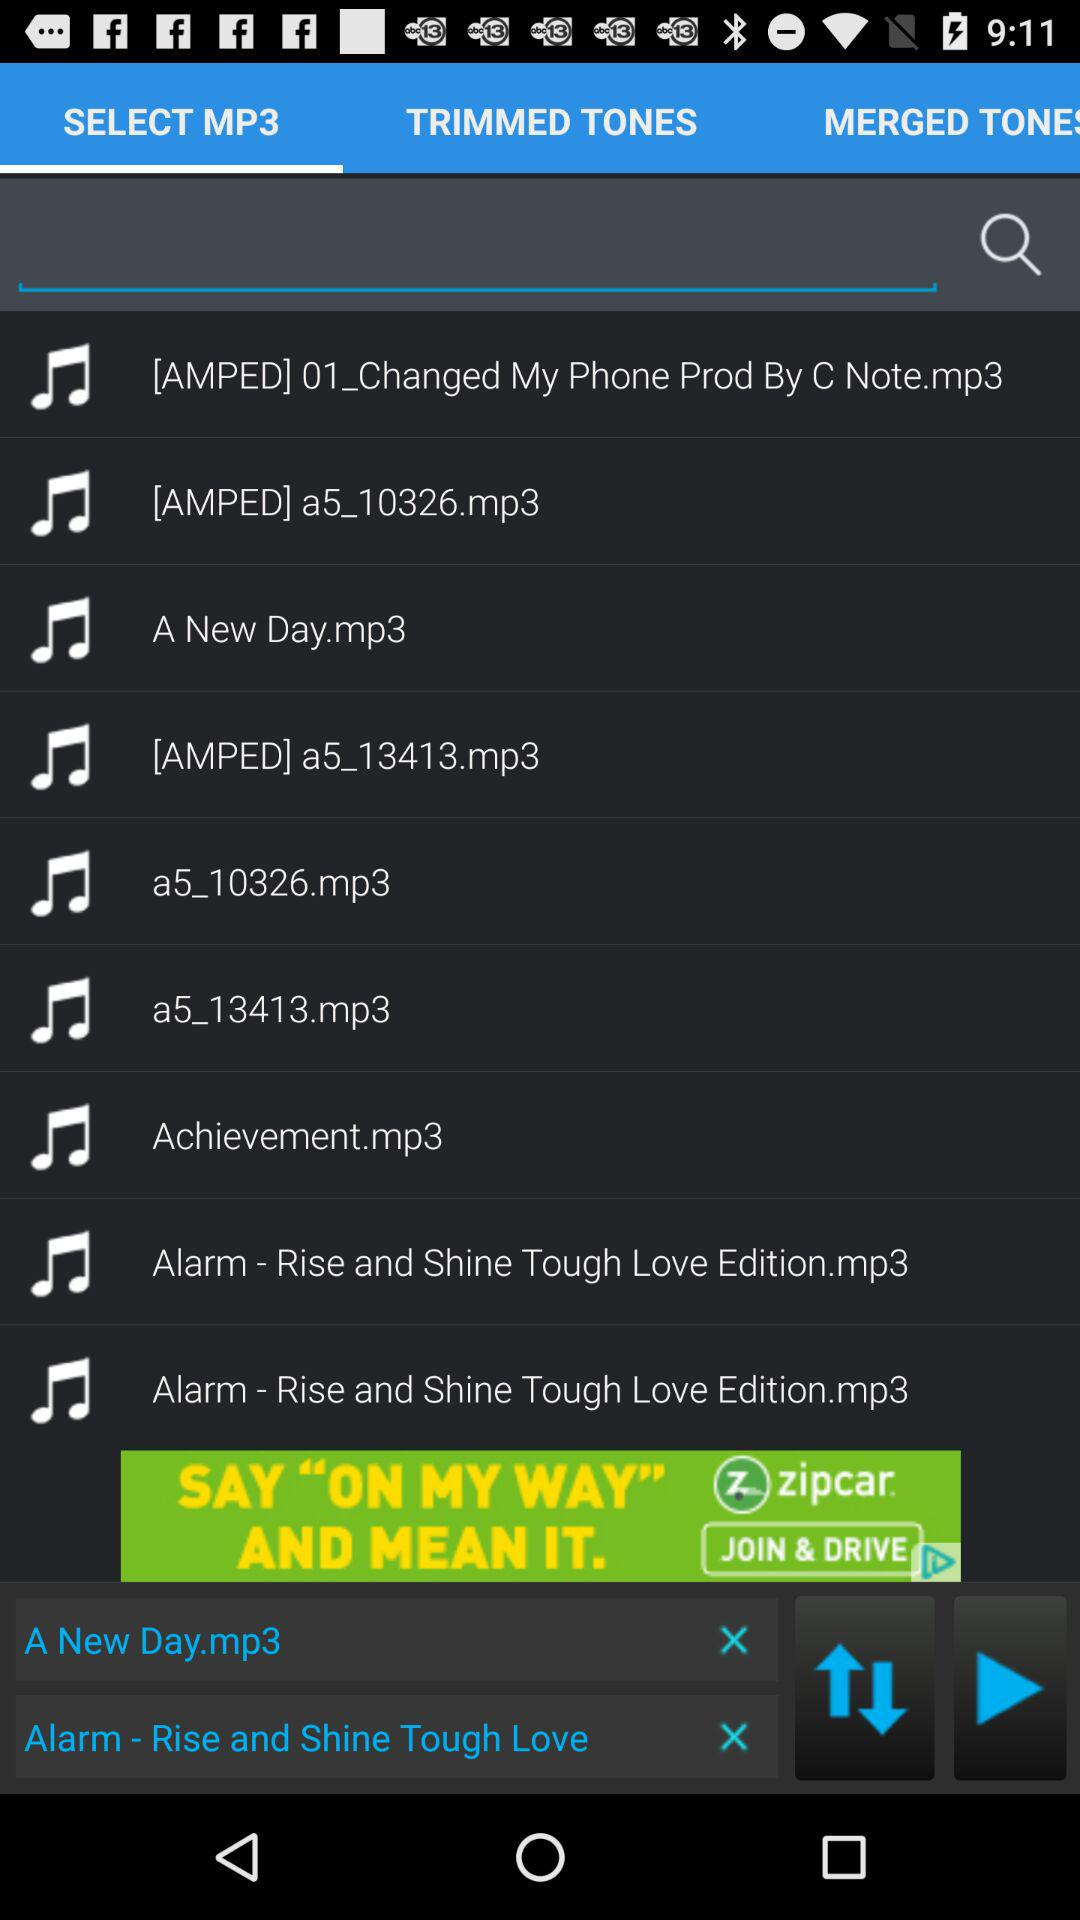Which tab is selected? The selected tab is "SELECT MP3". 